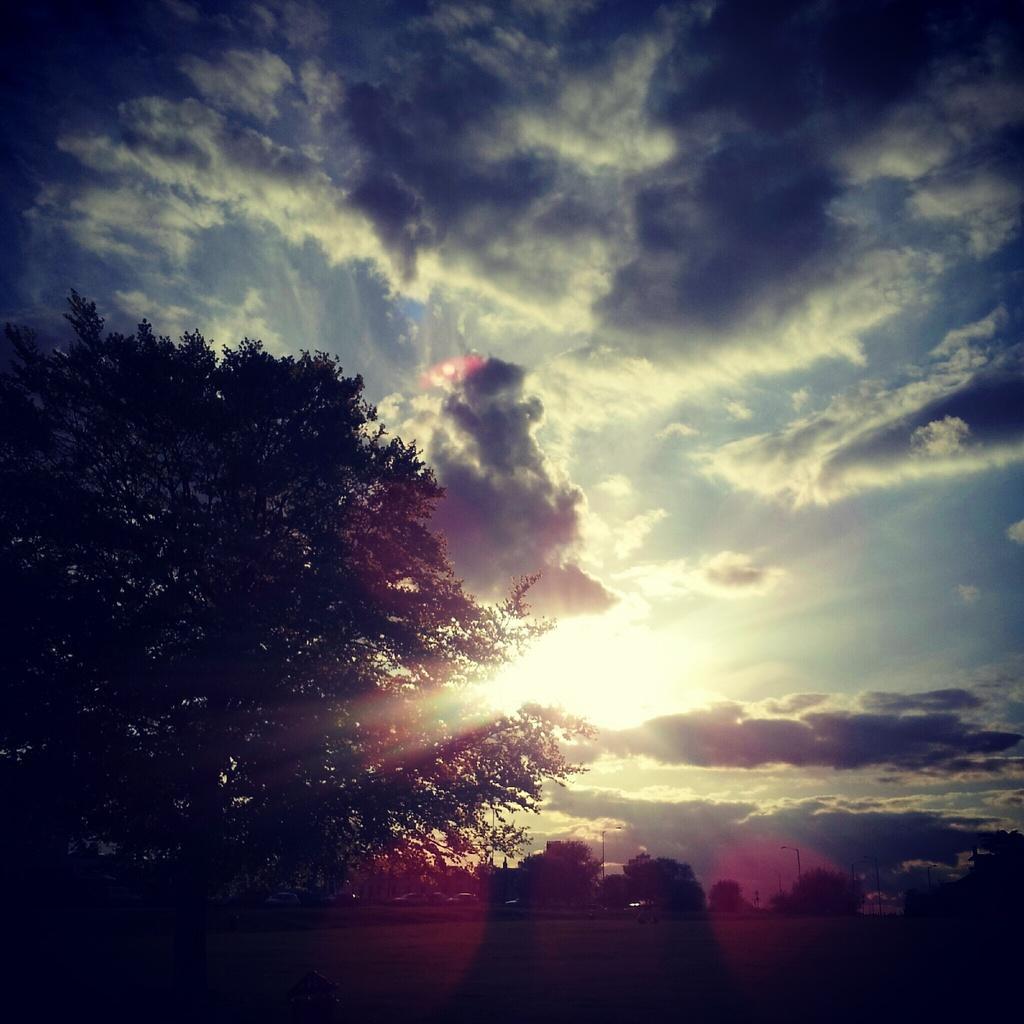How would you summarize this image in a sentence or two? In this image I can see trees, light poles and the sky. This image is taken may be on the ground. 